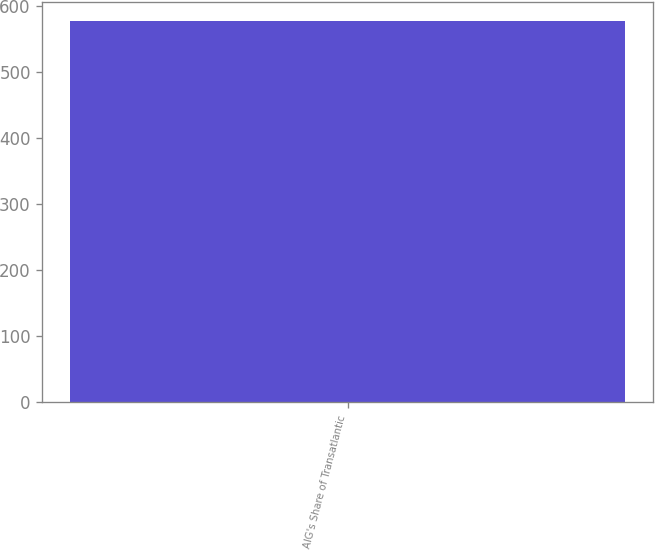Convert chart. <chart><loc_0><loc_0><loc_500><loc_500><bar_chart><fcel>AIG's Share of Transatlantic<nl><fcel>577<nl></chart> 